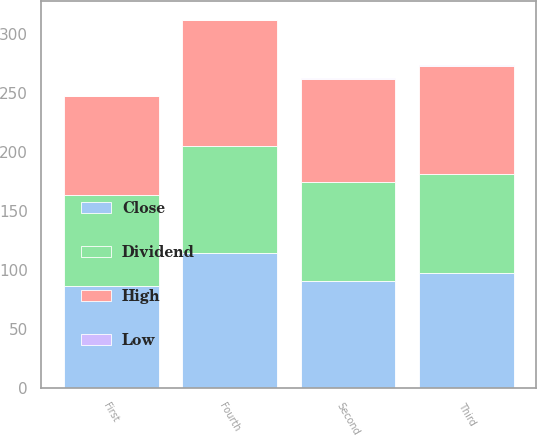<chart> <loc_0><loc_0><loc_500><loc_500><stacked_bar_chart><ecel><fcel>First<fcel>Second<fcel>Third<fcel>Fourth<nl><fcel>Close<fcel>86.31<fcel>90.34<fcel>97.12<fcel>114.75<nl><fcel>Dividend<fcel>76.78<fcel>84.15<fcel>84.04<fcel>90.12<nl><fcel>High<fcel>84.02<fcel>87.12<fcel>91.57<fcel>106.57<nl><fcel>Low<fcel>0.64<fcel>0.71<fcel>0.71<fcel>0.71<nl></chart> 